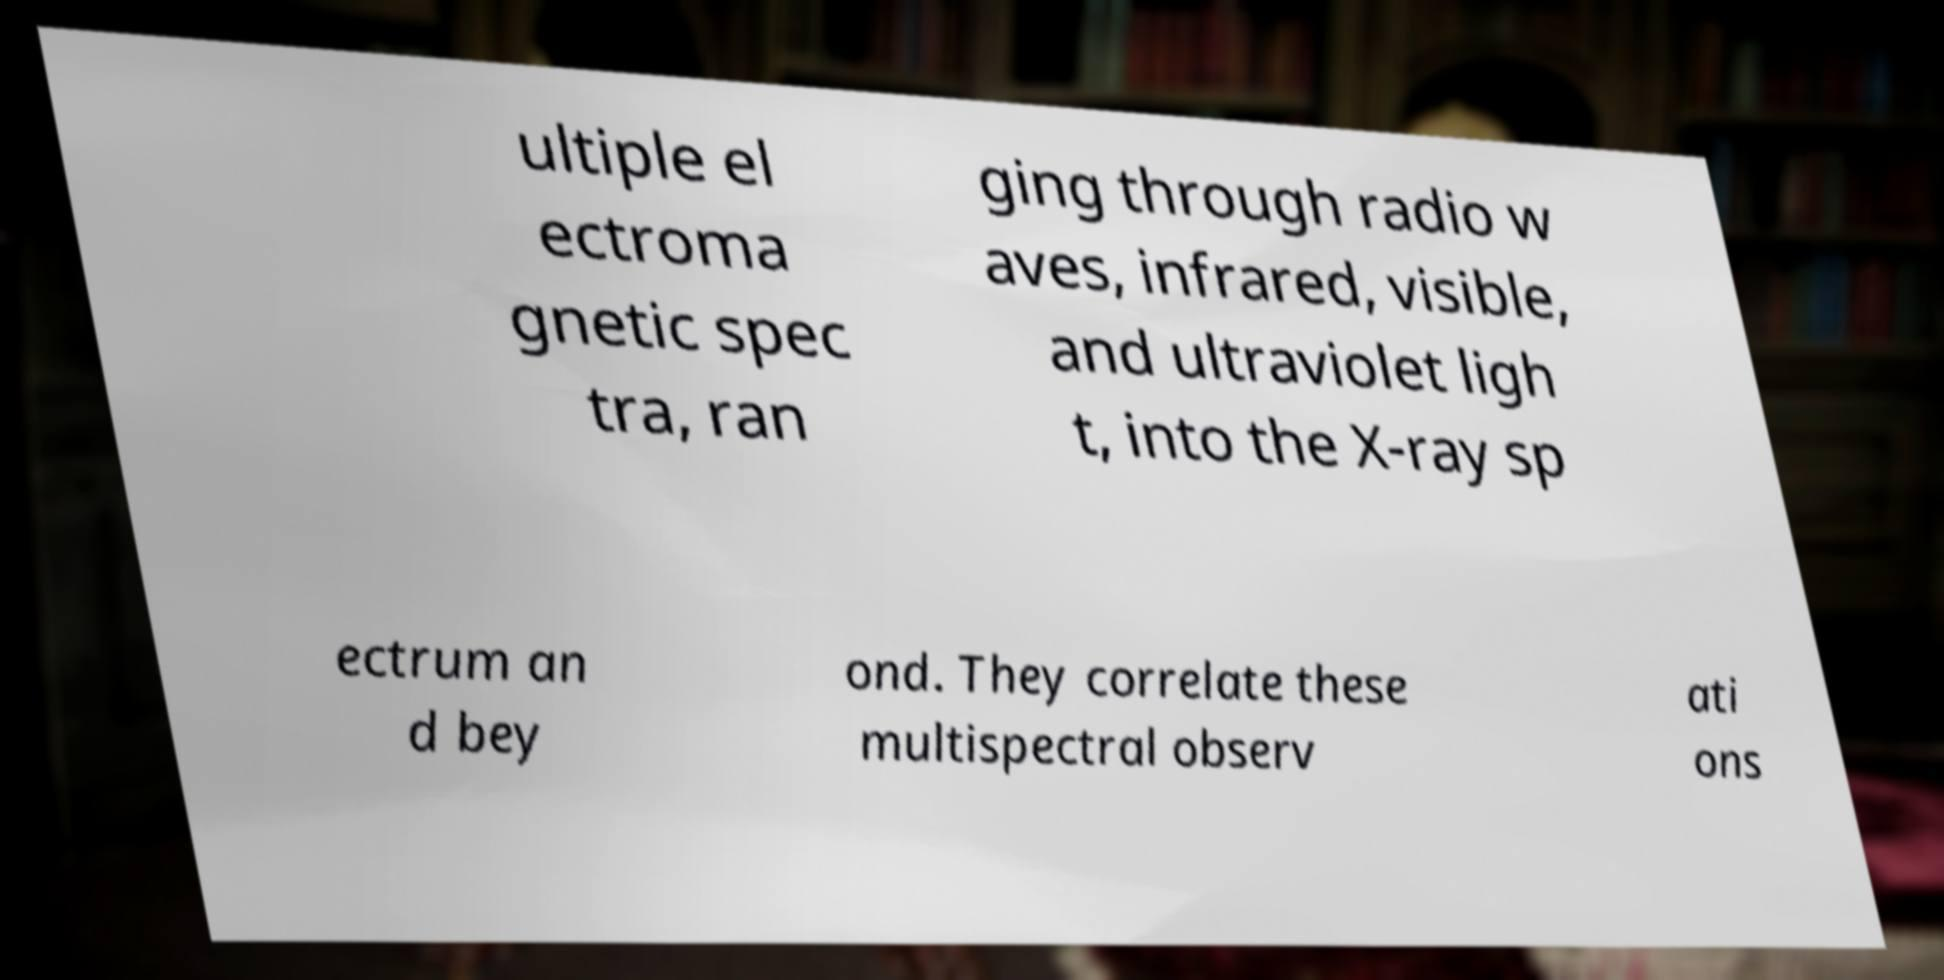Could you assist in decoding the text presented in this image and type it out clearly? ultiple el ectroma gnetic spec tra, ran ging through radio w aves, infrared, visible, and ultraviolet ligh t, into the X-ray sp ectrum an d bey ond. They correlate these multispectral observ ati ons 